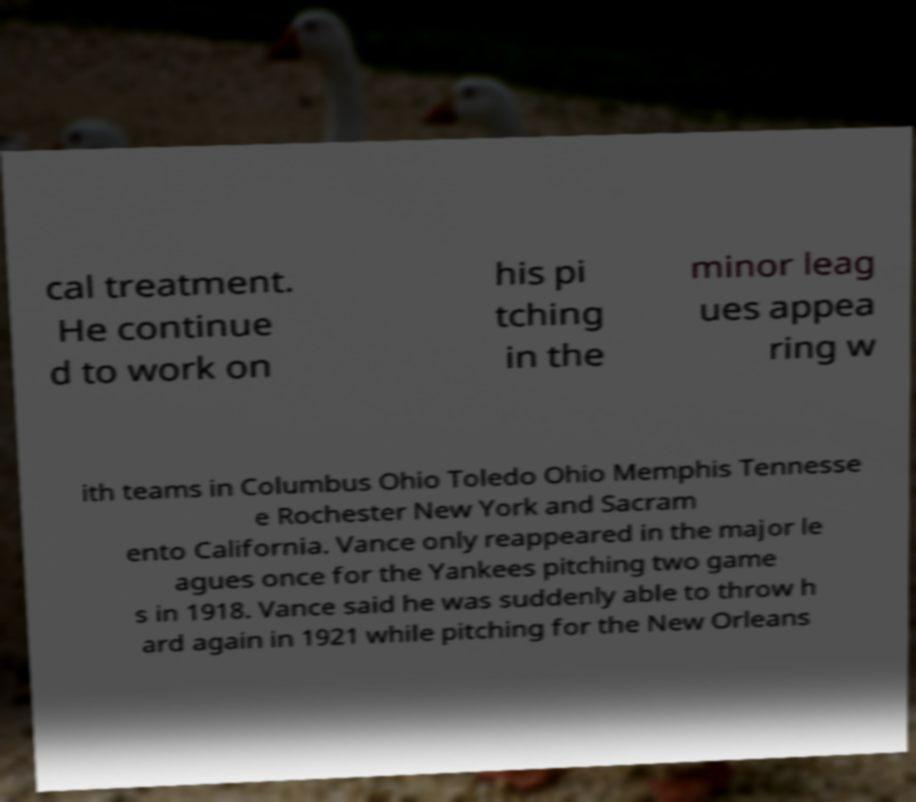Could you assist in decoding the text presented in this image and type it out clearly? cal treatment. He continue d to work on his pi tching in the minor leag ues appea ring w ith teams in Columbus Ohio Toledo Ohio Memphis Tennesse e Rochester New York and Sacram ento California. Vance only reappeared in the major le agues once for the Yankees pitching two game s in 1918. Vance said he was suddenly able to throw h ard again in 1921 while pitching for the New Orleans 